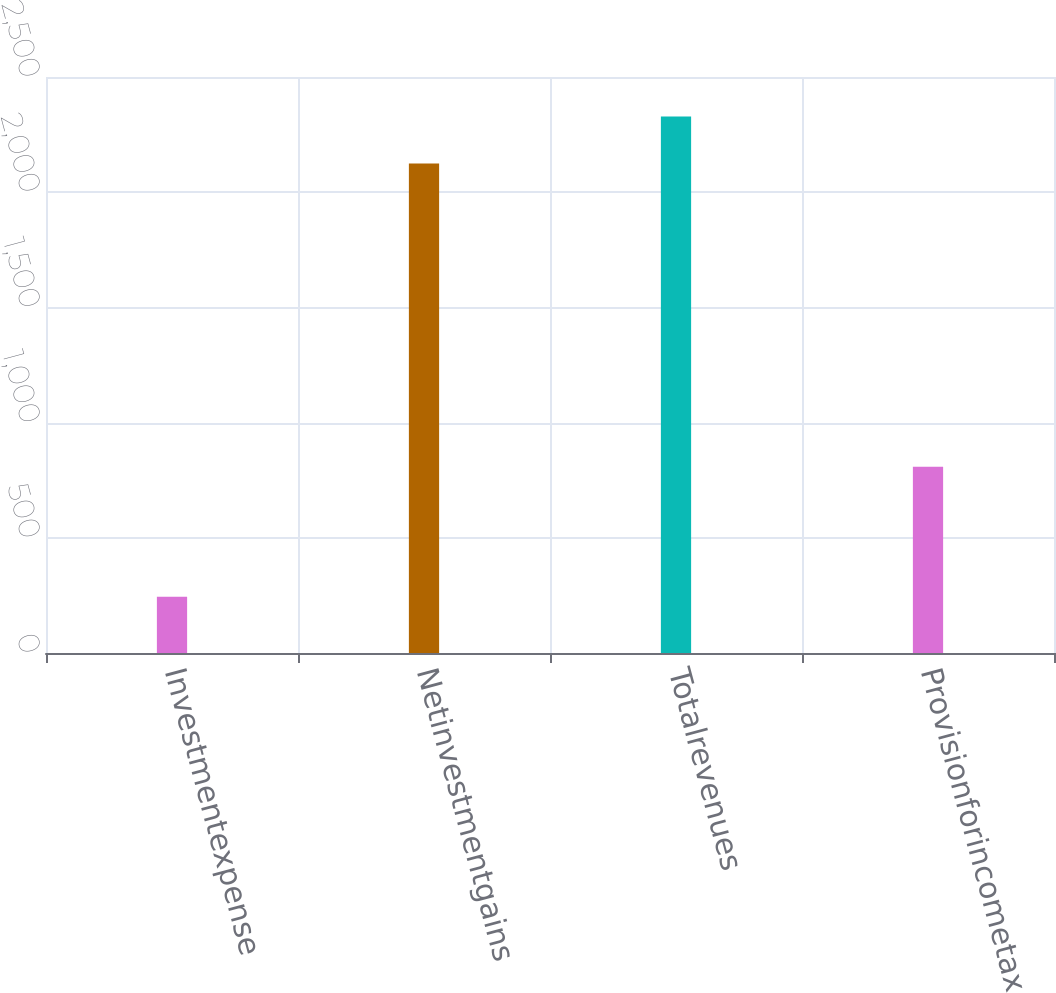Convert chart. <chart><loc_0><loc_0><loc_500><loc_500><bar_chart><fcel>Investmentexpense<fcel>Netinvestmentgains<fcel>Totalrevenues<fcel>Provisionforincometax<nl><fcel>244<fcel>2125<fcel>2328.2<fcel>808<nl></chart> 